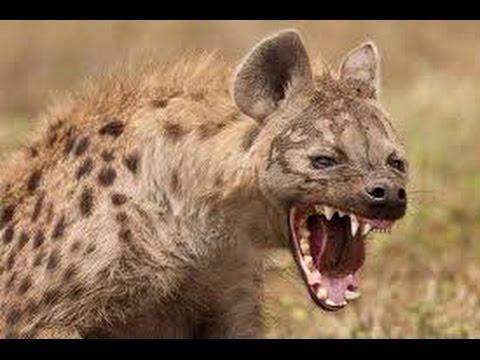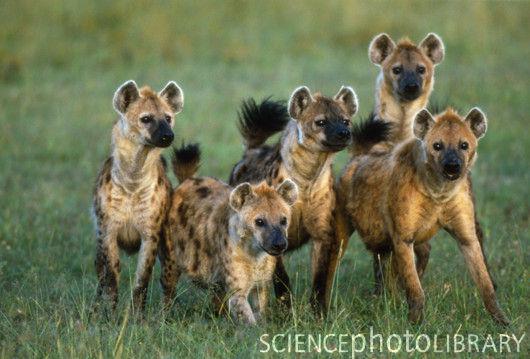The first image is the image on the left, the second image is the image on the right. Given the left and right images, does the statement "At least one image has a  single tan and black hyena opening its mouth showing its teeth." hold true? Answer yes or no. Yes. 